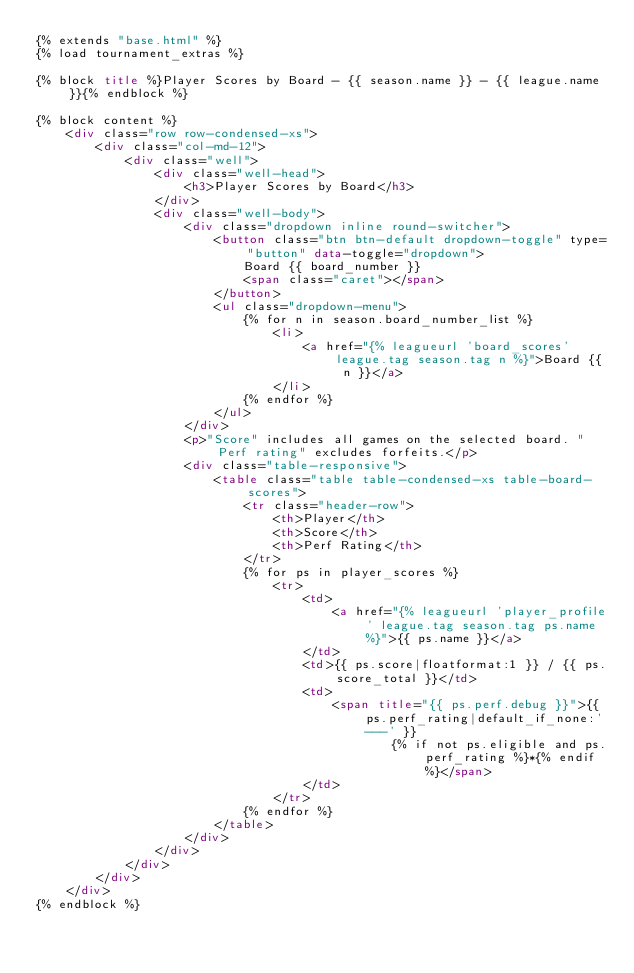Convert code to text. <code><loc_0><loc_0><loc_500><loc_500><_HTML_>{% extends "base.html" %}
{% load tournament_extras %}

{% block title %}Player Scores by Board - {{ season.name }} - {{ league.name }}{% endblock %}

{% block content %}
    <div class="row row-condensed-xs">
        <div class="col-md-12">
            <div class="well">
                <div class="well-head">
                    <h3>Player Scores by Board</h3>
                </div>
                <div class="well-body">
                    <div class="dropdown inline round-switcher">
                        <button class="btn btn-default dropdown-toggle" type="button" data-toggle="dropdown">
                            Board {{ board_number }}
                            <span class="caret"></span>
                        </button>
                        <ul class="dropdown-menu">
                            {% for n in season.board_number_list %}
                                <li>
                                    <a href="{% leagueurl 'board_scores' league.tag season.tag n %}">Board {{ n }}</a>
                                </li>
                            {% endfor %}
                        </ul>
                    </div>
                    <p>"Score" includes all games on the selected board. "Perf rating" excludes forfeits.</p>
                    <div class="table-responsive">
                        <table class="table table-condensed-xs table-board-scores">
                            <tr class="header-row">
                                <th>Player</th>
                                <th>Score</th>
                                <th>Perf Rating</th>
                            </tr>
                            {% for ps in player_scores %}
                                <tr>
                                    <td>
                                        <a href="{% leagueurl 'player_profile' league.tag season.tag ps.name %}">{{ ps.name }}</a>
                                    </td>
                                    <td>{{ ps.score|floatformat:1 }} / {{ ps.score_total }}</td>
                                    <td>
                                        <span title="{{ ps.perf.debug }}">{{ ps.perf_rating|default_if_none:'---' }}
                                                {% if not ps.eligible and ps.perf_rating %}*{% endif %}</span>
                                    </td>
                                </tr>
                            {% endfor %}
                        </table>
                    </div>
                </div>
            </div>
        </div>
    </div>
{% endblock %}
</code> 